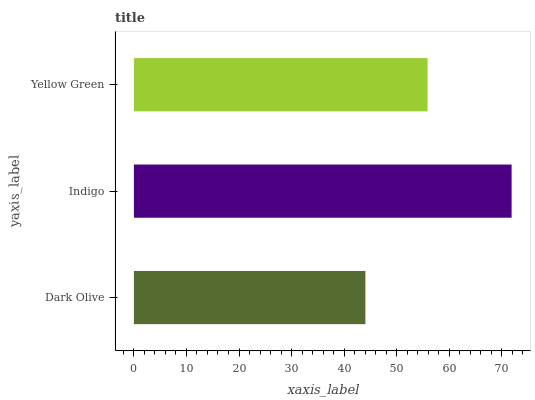Is Dark Olive the minimum?
Answer yes or no. Yes. Is Indigo the maximum?
Answer yes or no. Yes. Is Yellow Green the minimum?
Answer yes or no. No. Is Yellow Green the maximum?
Answer yes or no. No. Is Indigo greater than Yellow Green?
Answer yes or no. Yes. Is Yellow Green less than Indigo?
Answer yes or no. Yes. Is Yellow Green greater than Indigo?
Answer yes or no. No. Is Indigo less than Yellow Green?
Answer yes or no. No. Is Yellow Green the high median?
Answer yes or no. Yes. Is Yellow Green the low median?
Answer yes or no. Yes. Is Dark Olive the high median?
Answer yes or no. No. Is Dark Olive the low median?
Answer yes or no. No. 